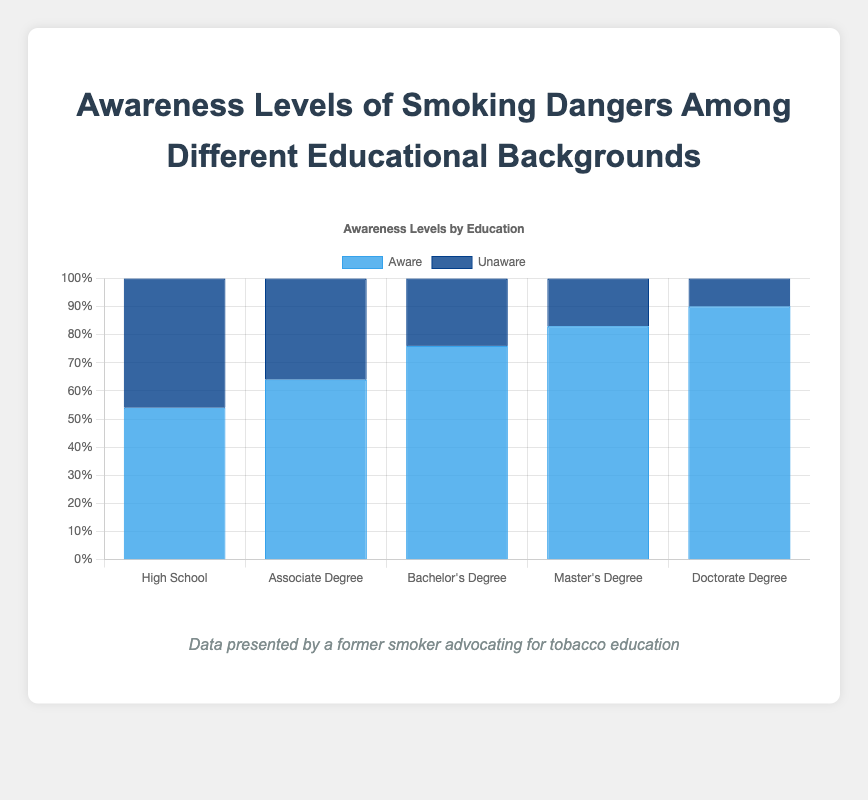what level of education has the highest awareness of smoking dangers? By observing the height of the blue bars, we can identify which education level has the highest awareness. The "Doctorate Degree" category has the tallest blue bar among all, indicating the highest awareness level.
Answer: Doctorate Degree what is the difference in awareness levels between Associate Degree and Master's Degree holders? To find the difference in awareness levels, subtract the awareness percentage of Associate Degree holders (64) from that of Master's Degree holders (83).
Answer: 19 which education level has the most people unaware of smoking dangers? By examining the height of the dark blue bars, we can determine which education level has the most people unaware. The "High School" category has the tallest dark blue bar, indicating the highest unawareness level.
Answer: High School what are the total awareness levels for both Bachelor's Degree and Master's Degree holders combined? Add the awareness levels for Bachelor's Degree holders (76) and Master's Degree holders (83). The sum is 76 + 83 = 159.
Answer: 159 what is the average awareness level across all education levels? To find the average awareness level, sum all the awareness values (54 + 64 + 76 + 83 + 90) and then divide by the number of education levels (5). The total sum is 367, and the average is 367/5.
Answer: 73.4 which education levels have awareness levels greater than 75? Identify the education levels with awareness percentages exceeding 75. "Bachelor's Degree" (76), "Master's Degree" (83), and "Doctorate Degree" (90) all meet this criterion.
Answer: Bachelor's Degree, Master's Degree, Doctorate Degree how does the awareness level of High School graduates compare to Doctorate Degree holders? The awareness level for High School graduates is 54, whereas for Doctorate Degree holders, it is 90. By simple comparison, Doctorate Degree holders have a higher awareness level.
Answer: Doctorate Degree holders have higher awareness how much higher is the awareness level of Bachelor's Degree holders compared to High School graduates? Subtract the awareness level of High School graduates (54) from that of Bachelor's Degree holders (76). The result is 76 - 54.
Answer: 22 what proportion of Master's Degree holders are unaware of smoking dangers? The percentage of Master's Degree holders unaware is 100% - awareness level (83%) = 17%. This calculation gives us the proportion of unawareness.
Answer: 17% is there a trend in awareness levels as the education level increases? By observing the bar heights, which correspond to increasing educational backgrounds, we notice a consistent increase in awareness as education level rises from High School to Doctorate Degree.
Answer: Awareness increases with education level 